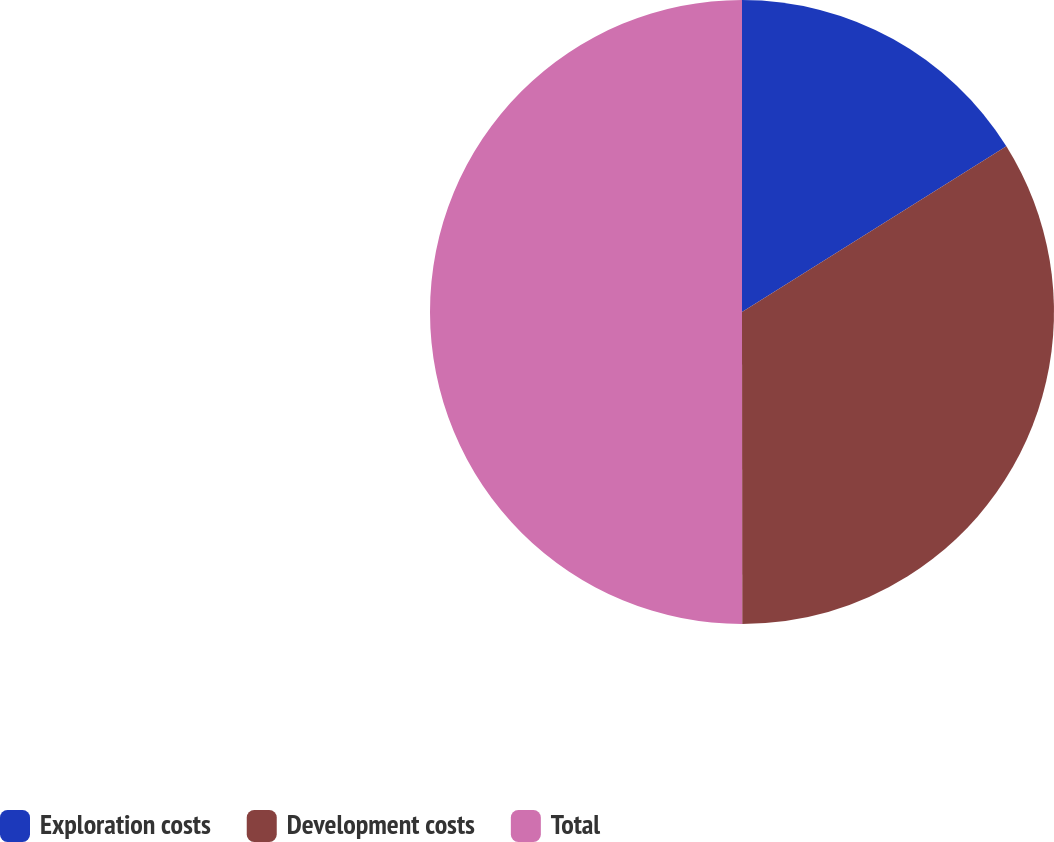Convert chart. <chart><loc_0><loc_0><loc_500><loc_500><pie_chart><fcel>Exploration costs<fcel>Development costs<fcel>Total<nl><fcel>16.09%<fcel>33.9%<fcel>50.01%<nl></chart> 